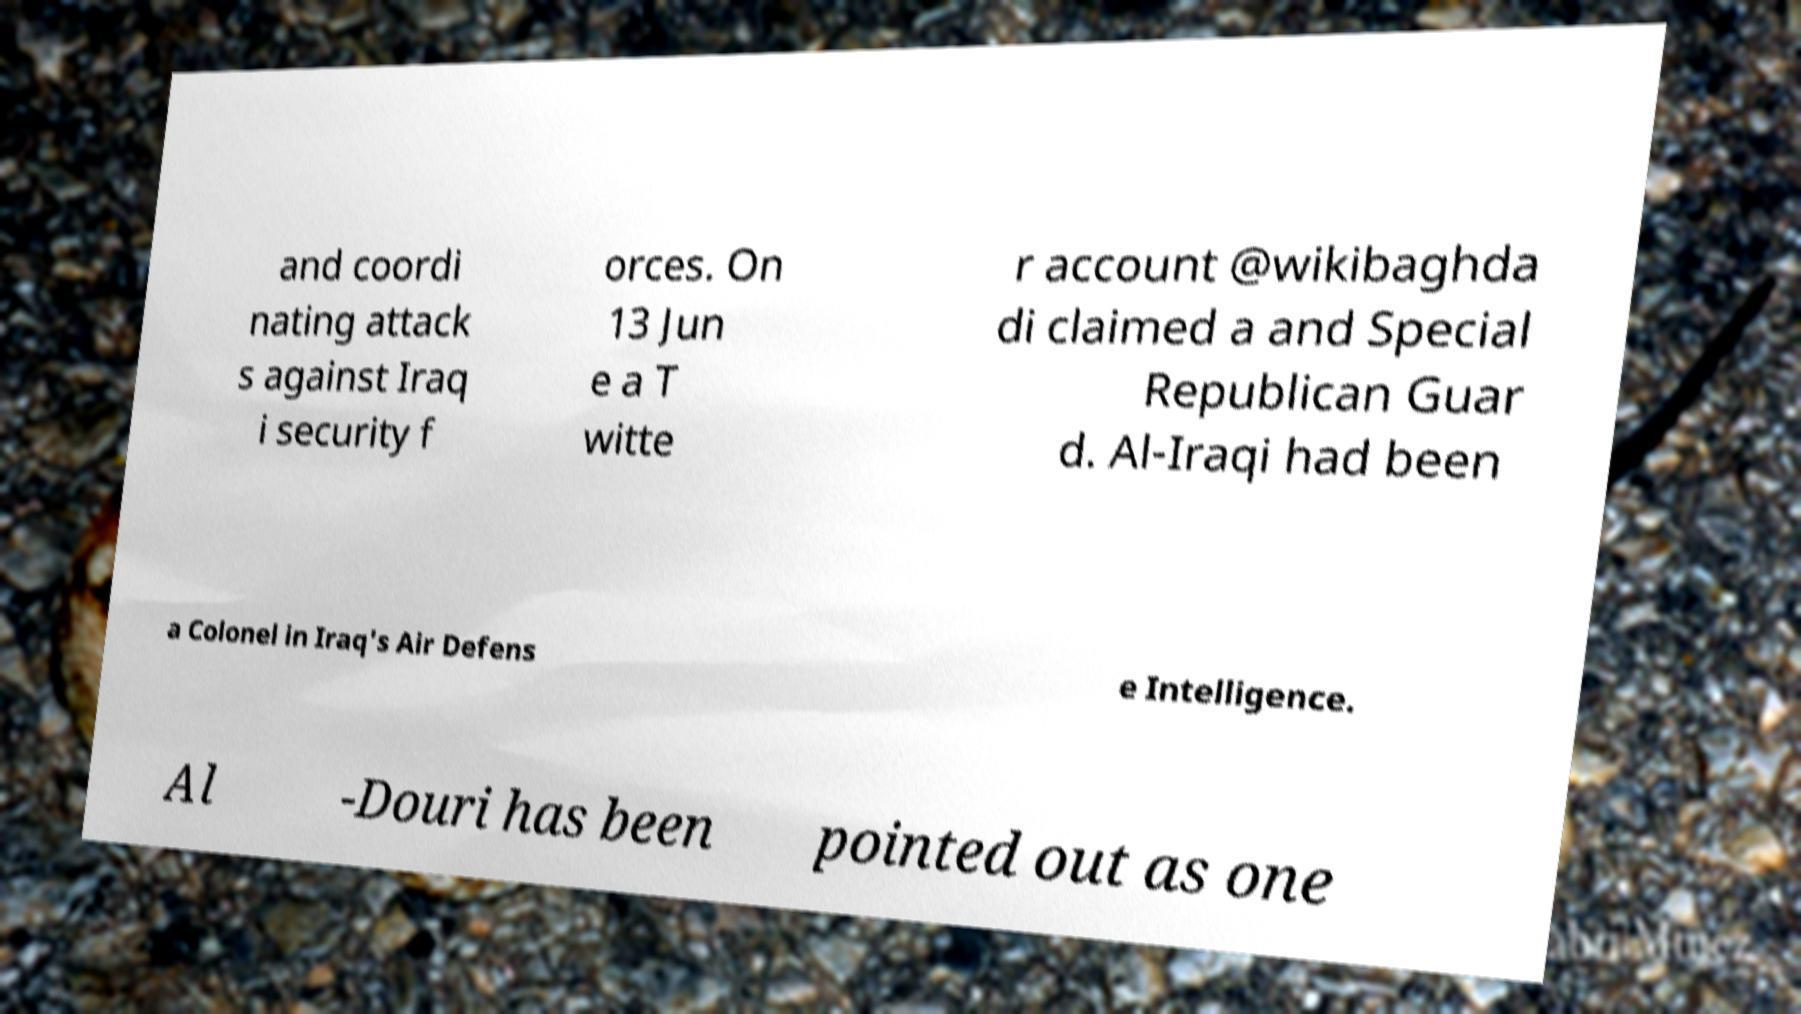Could you assist in decoding the text presented in this image and type it out clearly? and coordi nating attack s against Iraq i security f orces. On 13 Jun e a T witte r account @wikibaghda di claimed a and Special Republican Guar d. Al-Iraqi had been a Colonel in Iraq's Air Defens e Intelligence. Al -Douri has been pointed out as one 